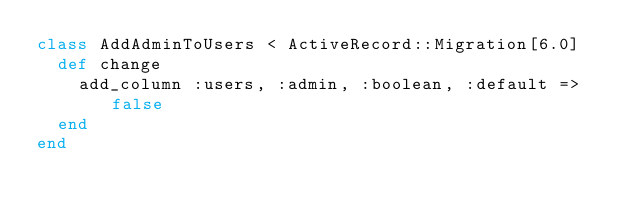Convert code to text. <code><loc_0><loc_0><loc_500><loc_500><_Ruby_>class AddAdminToUsers < ActiveRecord::Migration[6.0]
  def change
    add_column :users, :admin, :boolean, :default =>  false
  end
end
</code> 